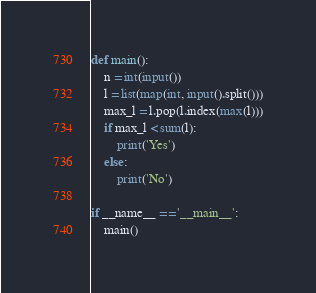Convert code to text. <code><loc_0><loc_0><loc_500><loc_500><_Python_>
def main():
    n = int(input())
    l = list(map(int, input().split()))
    max_l = l.pop(l.index(max(l)))
    if max_l < sum(l):
        print('Yes')
    else:
        print('No')

if __name__ == '__main__':
    main()
</code> 